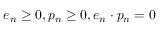<formula> <loc_0><loc_0><loc_500><loc_500>e _ { n } \geq 0 , p _ { n } \geq 0 , e _ { n } \cdot p _ { n } = 0 \,</formula> 